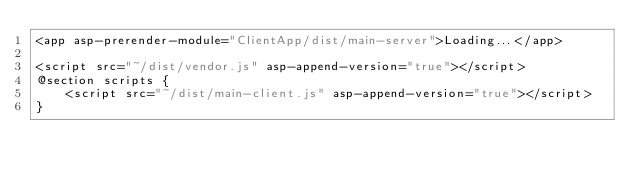Convert code to text. <code><loc_0><loc_0><loc_500><loc_500><_C#_><app asp-prerender-module="ClientApp/dist/main-server">Loading...</app>

<script src="~/dist/vendor.js" asp-append-version="true"></script>
@section scripts {
    <script src="~/dist/main-client.js" asp-append-version="true"></script>
}
</code> 